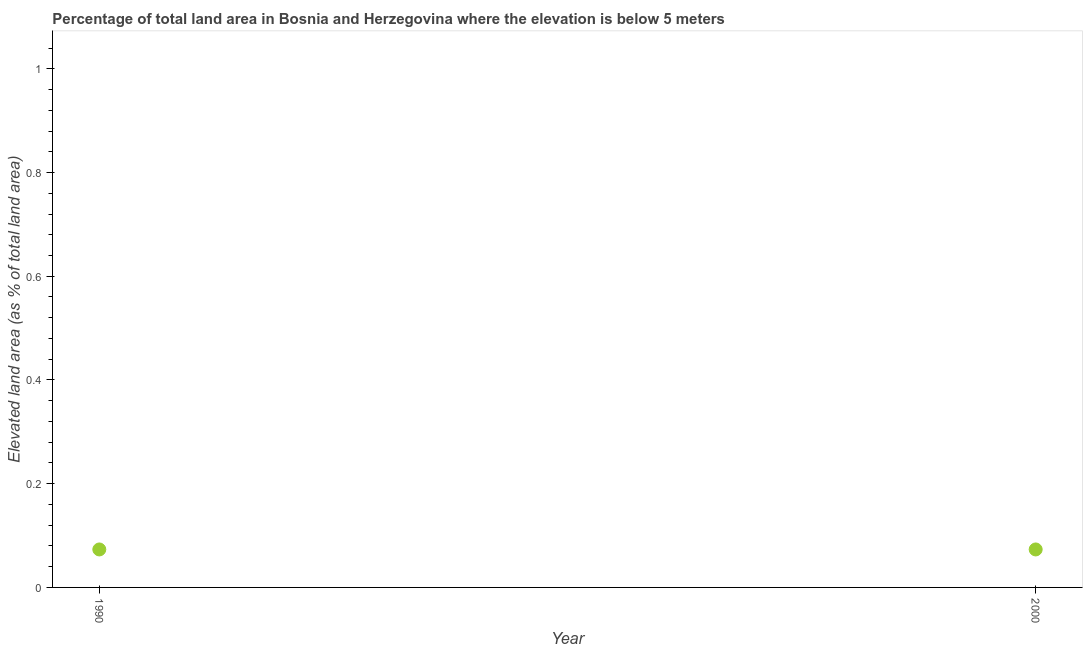What is the total elevated land area in 2000?
Give a very brief answer. 0.07. Across all years, what is the maximum total elevated land area?
Your answer should be very brief. 0.07. Across all years, what is the minimum total elevated land area?
Ensure brevity in your answer.  0.07. What is the sum of the total elevated land area?
Your answer should be compact. 0.15. What is the difference between the total elevated land area in 1990 and 2000?
Your response must be concise. 0. What is the average total elevated land area per year?
Your answer should be compact. 0.07. What is the median total elevated land area?
Provide a succinct answer. 0.07. Do a majority of the years between 2000 and 1990 (inclusive) have total elevated land area greater than 0.6400000000000001 %?
Your response must be concise. No. In how many years, is the total elevated land area greater than the average total elevated land area taken over all years?
Make the answer very short. 0. What is the difference between two consecutive major ticks on the Y-axis?
Provide a succinct answer. 0.2. Are the values on the major ticks of Y-axis written in scientific E-notation?
Your answer should be compact. No. Does the graph contain any zero values?
Your response must be concise. No. What is the title of the graph?
Your answer should be compact. Percentage of total land area in Bosnia and Herzegovina where the elevation is below 5 meters. What is the label or title of the Y-axis?
Keep it short and to the point. Elevated land area (as % of total land area). What is the Elevated land area (as % of total land area) in 1990?
Offer a very short reply. 0.07. What is the Elevated land area (as % of total land area) in 2000?
Offer a terse response. 0.07. What is the difference between the Elevated land area (as % of total land area) in 1990 and 2000?
Offer a very short reply. 0. What is the ratio of the Elevated land area (as % of total land area) in 1990 to that in 2000?
Ensure brevity in your answer.  1. 